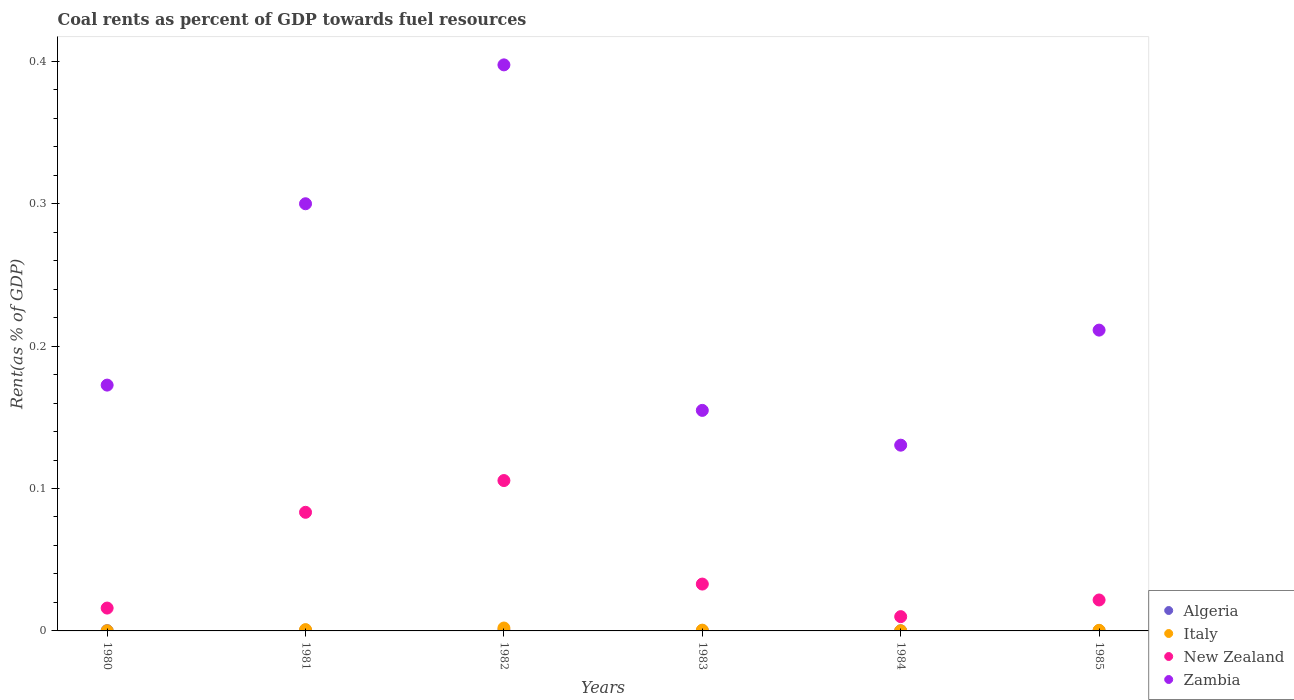How many different coloured dotlines are there?
Ensure brevity in your answer.  4. Is the number of dotlines equal to the number of legend labels?
Your answer should be compact. Yes. What is the coal rent in Zambia in 1980?
Your answer should be very brief. 0.17. Across all years, what is the maximum coal rent in Italy?
Your answer should be compact. 0. Across all years, what is the minimum coal rent in Italy?
Give a very brief answer. 9.6418290567852e-5. In which year was the coal rent in New Zealand maximum?
Make the answer very short. 1982. In which year was the coal rent in Algeria minimum?
Offer a terse response. 1984. What is the total coal rent in Italy in the graph?
Give a very brief answer. 0. What is the difference between the coal rent in Italy in 1980 and that in 1983?
Your answer should be compact. -0. What is the difference between the coal rent in Zambia in 1984 and the coal rent in Italy in 1983?
Provide a short and direct response. 0.13. What is the average coal rent in Algeria per year?
Provide a succinct answer. 0. In the year 1984, what is the difference between the coal rent in New Zealand and coal rent in Italy?
Give a very brief answer. 0.01. In how many years, is the coal rent in New Zealand greater than 0.12000000000000001 %?
Keep it short and to the point. 0. What is the ratio of the coal rent in Italy in 1981 to that in 1985?
Make the answer very short. 2.21. Is the coal rent in New Zealand in 1981 less than that in 1985?
Offer a terse response. No. Is the difference between the coal rent in New Zealand in 1983 and 1984 greater than the difference between the coal rent in Italy in 1983 and 1984?
Give a very brief answer. Yes. What is the difference between the highest and the second highest coal rent in Italy?
Offer a very short reply. 0. What is the difference between the highest and the lowest coal rent in New Zealand?
Provide a succinct answer. 0.1. In how many years, is the coal rent in New Zealand greater than the average coal rent in New Zealand taken over all years?
Offer a terse response. 2. Is the sum of the coal rent in Italy in 1981 and 1984 greater than the maximum coal rent in New Zealand across all years?
Ensure brevity in your answer.  No. Is it the case that in every year, the sum of the coal rent in Algeria and coal rent in Italy  is greater than the sum of coal rent in Zambia and coal rent in New Zealand?
Give a very brief answer. No. Does the coal rent in Zambia monotonically increase over the years?
Keep it short and to the point. No. Is the coal rent in Algeria strictly less than the coal rent in New Zealand over the years?
Your response must be concise. Yes. Are the values on the major ticks of Y-axis written in scientific E-notation?
Offer a terse response. No. Does the graph contain any zero values?
Ensure brevity in your answer.  No. How many legend labels are there?
Your response must be concise. 4. How are the legend labels stacked?
Offer a terse response. Vertical. What is the title of the graph?
Your answer should be compact. Coal rents as percent of GDP towards fuel resources. Does "Fiji" appear as one of the legend labels in the graph?
Provide a succinct answer. No. What is the label or title of the X-axis?
Your answer should be very brief. Years. What is the label or title of the Y-axis?
Provide a succinct answer. Rent(as % of GDP). What is the Rent(as % of GDP) in Algeria in 1980?
Your answer should be very brief. 0. What is the Rent(as % of GDP) in Italy in 1980?
Your response must be concise. 9.6418290567852e-5. What is the Rent(as % of GDP) of New Zealand in 1980?
Give a very brief answer. 0.02. What is the Rent(as % of GDP) of Zambia in 1980?
Make the answer very short. 0.17. What is the Rent(as % of GDP) in Algeria in 1981?
Make the answer very short. 0. What is the Rent(as % of GDP) of Italy in 1981?
Give a very brief answer. 0. What is the Rent(as % of GDP) of New Zealand in 1981?
Give a very brief answer. 0.08. What is the Rent(as % of GDP) of Zambia in 1981?
Offer a very short reply. 0.3. What is the Rent(as % of GDP) of Algeria in 1982?
Your answer should be compact. 0. What is the Rent(as % of GDP) in Italy in 1982?
Offer a terse response. 0. What is the Rent(as % of GDP) of New Zealand in 1982?
Ensure brevity in your answer.  0.11. What is the Rent(as % of GDP) of Zambia in 1982?
Ensure brevity in your answer.  0.4. What is the Rent(as % of GDP) of Algeria in 1983?
Ensure brevity in your answer.  0. What is the Rent(as % of GDP) of Italy in 1983?
Ensure brevity in your answer.  0. What is the Rent(as % of GDP) in New Zealand in 1983?
Your response must be concise. 0.03. What is the Rent(as % of GDP) in Zambia in 1983?
Offer a very short reply. 0.15. What is the Rent(as % of GDP) of Algeria in 1984?
Offer a terse response. 6.52912655872695e-5. What is the Rent(as % of GDP) in Italy in 1984?
Provide a succinct answer. 0. What is the Rent(as % of GDP) of New Zealand in 1984?
Offer a terse response. 0.01. What is the Rent(as % of GDP) of Zambia in 1984?
Your answer should be compact. 0.13. What is the Rent(as % of GDP) in Algeria in 1985?
Make the answer very short. 0. What is the Rent(as % of GDP) in Italy in 1985?
Ensure brevity in your answer.  0. What is the Rent(as % of GDP) in New Zealand in 1985?
Offer a very short reply. 0.02. What is the Rent(as % of GDP) in Zambia in 1985?
Provide a short and direct response. 0.21. Across all years, what is the maximum Rent(as % of GDP) in Algeria?
Keep it short and to the point. 0. Across all years, what is the maximum Rent(as % of GDP) of Italy?
Your answer should be compact. 0. Across all years, what is the maximum Rent(as % of GDP) of New Zealand?
Provide a succinct answer. 0.11. Across all years, what is the maximum Rent(as % of GDP) of Zambia?
Give a very brief answer. 0.4. Across all years, what is the minimum Rent(as % of GDP) of Algeria?
Your answer should be compact. 6.52912655872695e-5. Across all years, what is the minimum Rent(as % of GDP) in Italy?
Offer a very short reply. 9.6418290567852e-5. Across all years, what is the minimum Rent(as % of GDP) of New Zealand?
Keep it short and to the point. 0.01. Across all years, what is the minimum Rent(as % of GDP) of Zambia?
Your answer should be compact. 0.13. What is the total Rent(as % of GDP) of Algeria in the graph?
Your answer should be compact. 0. What is the total Rent(as % of GDP) in Italy in the graph?
Make the answer very short. 0. What is the total Rent(as % of GDP) of New Zealand in the graph?
Make the answer very short. 0.27. What is the total Rent(as % of GDP) in Zambia in the graph?
Your response must be concise. 1.37. What is the difference between the Rent(as % of GDP) of Algeria in 1980 and that in 1981?
Your answer should be compact. -0. What is the difference between the Rent(as % of GDP) in Italy in 1980 and that in 1981?
Ensure brevity in your answer.  -0. What is the difference between the Rent(as % of GDP) in New Zealand in 1980 and that in 1981?
Offer a very short reply. -0.07. What is the difference between the Rent(as % of GDP) in Zambia in 1980 and that in 1981?
Keep it short and to the point. -0.13. What is the difference between the Rent(as % of GDP) in Algeria in 1980 and that in 1982?
Provide a short and direct response. -0. What is the difference between the Rent(as % of GDP) of Italy in 1980 and that in 1982?
Keep it short and to the point. -0. What is the difference between the Rent(as % of GDP) in New Zealand in 1980 and that in 1982?
Make the answer very short. -0.09. What is the difference between the Rent(as % of GDP) of Zambia in 1980 and that in 1982?
Your answer should be compact. -0.22. What is the difference between the Rent(as % of GDP) of Italy in 1980 and that in 1983?
Give a very brief answer. -0. What is the difference between the Rent(as % of GDP) of New Zealand in 1980 and that in 1983?
Give a very brief answer. -0.02. What is the difference between the Rent(as % of GDP) of Zambia in 1980 and that in 1983?
Provide a succinct answer. 0.02. What is the difference between the Rent(as % of GDP) in Algeria in 1980 and that in 1984?
Offer a terse response. 0. What is the difference between the Rent(as % of GDP) of Italy in 1980 and that in 1984?
Offer a very short reply. -0. What is the difference between the Rent(as % of GDP) of New Zealand in 1980 and that in 1984?
Provide a succinct answer. 0.01. What is the difference between the Rent(as % of GDP) of Zambia in 1980 and that in 1984?
Provide a succinct answer. 0.04. What is the difference between the Rent(as % of GDP) in Italy in 1980 and that in 1985?
Keep it short and to the point. -0. What is the difference between the Rent(as % of GDP) in New Zealand in 1980 and that in 1985?
Your answer should be compact. -0.01. What is the difference between the Rent(as % of GDP) in Zambia in 1980 and that in 1985?
Your response must be concise. -0.04. What is the difference between the Rent(as % of GDP) of Algeria in 1981 and that in 1982?
Offer a terse response. -0. What is the difference between the Rent(as % of GDP) in Italy in 1981 and that in 1982?
Provide a short and direct response. -0. What is the difference between the Rent(as % of GDP) in New Zealand in 1981 and that in 1982?
Offer a very short reply. -0.02. What is the difference between the Rent(as % of GDP) of Zambia in 1981 and that in 1982?
Keep it short and to the point. -0.1. What is the difference between the Rent(as % of GDP) of Algeria in 1981 and that in 1983?
Your response must be concise. 0. What is the difference between the Rent(as % of GDP) in Italy in 1981 and that in 1983?
Give a very brief answer. 0. What is the difference between the Rent(as % of GDP) in New Zealand in 1981 and that in 1983?
Provide a succinct answer. 0.05. What is the difference between the Rent(as % of GDP) in Zambia in 1981 and that in 1983?
Provide a short and direct response. 0.15. What is the difference between the Rent(as % of GDP) in Italy in 1981 and that in 1984?
Provide a succinct answer. 0. What is the difference between the Rent(as % of GDP) in New Zealand in 1981 and that in 1984?
Offer a very short reply. 0.07. What is the difference between the Rent(as % of GDP) of Zambia in 1981 and that in 1984?
Your response must be concise. 0.17. What is the difference between the Rent(as % of GDP) in Algeria in 1981 and that in 1985?
Make the answer very short. 0. What is the difference between the Rent(as % of GDP) in Italy in 1981 and that in 1985?
Give a very brief answer. 0. What is the difference between the Rent(as % of GDP) of New Zealand in 1981 and that in 1985?
Your response must be concise. 0.06. What is the difference between the Rent(as % of GDP) in Zambia in 1981 and that in 1985?
Give a very brief answer. 0.09. What is the difference between the Rent(as % of GDP) in Algeria in 1982 and that in 1983?
Offer a very short reply. 0. What is the difference between the Rent(as % of GDP) in Italy in 1982 and that in 1983?
Your answer should be very brief. 0. What is the difference between the Rent(as % of GDP) in New Zealand in 1982 and that in 1983?
Make the answer very short. 0.07. What is the difference between the Rent(as % of GDP) in Zambia in 1982 and that in 1983?
Your response must be concise. 0.24. What is the difference between the Rent(as % of GDP) of Italy in 1982 and that in 1984?
Keep it short and to the point. 0. What is the difference between the Rent(as % of GDP) of New Zealand in 1982 and that in 1984?
Ensure brevity in your answer.  0.1. What is the difference between the Rent(as % of GDP) in Zambia in 1982 and that in 1984?
Your answer should be compact. 0.27. What is the difference between the Rent(as % of GDP) of Algeria in 1982 and that in 1985?
Give a very brief answer. 0. What is the difference between the Rent(as % of GDP) of Italy in 1982 and that in 1985?
Provide a succinct answer. 0. What is the difference between the Rent(as % of GDP) of New Zealand in 1982 and that in 1985?
Ensure brevity in your answer.  0.08. What is the difference between the Rent(as % of GDP) of Zambia in 1982 and that in 1985?
Give a very brief answer. 0.19. What is the difference between the Rent(as % of GDP) in Algeria in 1983 and that in 1984?
Your answer should be compact. 0. What is the difference between the Rent(as % of GDP) in New Zealand in 1983 and that in 1984?
Provide a short and direct response. 0.02. What is the difference between the Rent(as % of GDP) in Zambia in 1983 and that in 1984?
Offer a terse response. 0.02. What is the difference between the Rent(as % of GDP) in Algeria in 1983 and that in 1985?
Give a very brief answer. 0. What is the difference between the Rent(as % of GDP) in New Zealand in 1983 and that in 1985?
Your answer should be very brief. 0.01. What is the difference between the Rent(as % of GDP) in Zambia in 1983 and that in 1985?
Provide a short and direct response. -0.06. What is the difference between the Rent(as % of GDP) of Italy in 1984 and that in 1985?
Provide a succinct answer. -0. What is the difference between the Rent(as % of GDP) in New Zealand in 1984 and that in 1985?
Make the answer very short. -0.01. What is the difference between the Rent(as % of GDP) in Zambia in 1984 and that in 1985?
Your answer should be very brief. -0.08. What is the difference between the Rent(as % of GDP) of Algeria in 1980 and the Rent(as % of GDP) of Italy in 1981?
Make the answer very short. -0. What is the difference between the Rent(as % of GDP) of Algeria in 1980 and the Rent(as % of GDP) of New Zealand in 1981?
Offer a terse response. -0.08. What is the difference between the Rent(as % of GDP) of Algeria in 1980 and the Rent(as % of GDP) of Zambia in 1981?
Make the answer very short. -0.3. What is the difference between the Rent(as % of GDP) of Italy in 1980 and the Rent(as % of GDP) of New Zealand in 1981?
Keep it short and to the point. -0.08. What is the difference between the Rent(as % of GDP) in Italy in 1980 and the Rent(as % of GDP) in Zambia in 1981?
Give a very brief answer. -0.3. What is the difference between the Rent(as % of GDP) in New Zealand in 1980 and the Rent(as % of GDP) in Zambia in 1981?
Keep it short and to the point. -0.28. What is the difference between the Rent(as % of GDP) of Algeria in 1980 and the Rent(as % of GDP) of Italy in 1982?
Your response must be concise. -0. What is the difference between the Rent(as % of GDP) in Algeria in 1980 and the Rent(as % of GDP) in New Zealand in 1982?
Ensure brevity in your answer.  -0.11. What is the difference between the Rent(as % of GDP) of Algeria in 1980 and the Rent(as % of GDP) of Zambia in 1982?
Keep it short and to the point. -0.4. What is the difference between the Rent(as % of GDP) of Italy in 1980 and the Rent(as % of GDP) of New Zealand in 1982?
Provide a succinct answer. -0.11. What is the difference between the Rent(as % of GDP) of Italy in 1980 and the Rent(as % of GDP) of Zambia in 1982?
Provide a succinct answer. -0.4. What is the difference between the Rent(as % of GDP) in New Zealand in 1980 and the Rent(as % of GDP) in Zambia in 1982?
Provide a succinct answer. -0.38. What is the difference between the Rent(as % of GDP) in Algeria in 1980 and the Rent(as % of GDP) in Italy in 1983?
Offer a very short reply. -0. What is the difference between the Rent(as % of GDP) in Algeria in 1980 and the Rent(as % of GDP) in New Zealand in 1983?
Your answer should be compact. -0.03. What is the difference between the Rent(as % of GDP) of Algeria in 1980 and the Rent(as % of GDP) of Zambia in 1983?
Give a very brief answer. -0.15. What is the difference between the Rent(as % of GDP) of Italy in 1980 and the Rent(as % of GDP) of New Zealand in 1983?
Provide a short and direct response. -0.03. What is the difference between the Rent(as % of GDP) of Italy in 1980 and the Rent(as % of GDP) of Zambia in 1983?
Give a very brief answer. -0.15. What is the difference between the Rent(as % of GDP) in New Zealand in 1980 and the Rent(as % of GDP) in Zambia in 1983?
Provide a short and direct response. -0.14. What is the difference between the Rent(as % of GDP) of Algeria in 1980 and the Rent(as % of GDP) of Italy in 1984?
Provide a short and direct response. 0. What is the difference between the Rent(as % of GDP) of Algeria in 1980 and the Rent(as % of GDP) of New Zealand in 1984?
Keep it short and to the point. -0.01. What is the difference between the Rent(as % of GDP) of Algeria in 1980 and the Rent(as % of GDP) of Zambia in 1984?
Offer a very short reply. -0.13. What is the difference between the Rent(as % of GDP) of Italy in 1980 and the Rent(as % of GDP) of New Zealand in 1984?
Offer a very short reply. -0.01. What is the difference between the Rent(as % of GDP) in Italy in 1980 and the Rent(as % of GDP) in Zambia in 1984?
Provide a short and direct response. -0.13. What is the difference between the Rent(as % of GDP) of New Zealand in 1980 and the Rent(as % of GDP) of Zambia in 1984?
Provide a succinct answer. -0.11. What is the difference between the Rent(as % of GDP) of Algeria in 1980 and the Rent(as % of GDP) of Italy in 1985?
Offer a very short reply. -0. What is the difference between the Rent(as % of GDP) of Algeria in 1980 and the Rent(as % of GDP) of New Zealand in 1985?
Your answer should be very brief. -0.02. What is the difference between the Rent(as % of GDP) in Algeria in 1980 and the Rent(as % of GDP) in Zambia in 1985?
Provide a succinct answer. -0.21. What is the difference between the Rent(as % of GDP) of Italy in 1980 and the Rent(as % of GDP) of New Zealand in 1985?
Your answer should be compact. -0.02. What is the difference between the Rent(as % of GDP) of Italy in 1980 and the Rent(as % of GDP) of Zambia in 1985?
Provide a succinct answer. -0.21. What is the difference between the Rent(as % of GDP) in New Zealand in 1980 and the Rent(as % of GDP) in Zambia in 1985?
Give a very brief answer. -0.2. What is the difference between the Rent(as % of GDP) in Algeria in 1981 and the Rent(as % of GDP) in Italy in 1982?
Provide a succinct answer. -0. What is the difference between the Rent(as % of GDP) of Algeria in 1981 and the Rent(as % of GDP) of New Zealand in 1982?
Keep it short and to the point. -0.11. What is the difference between the Rent(as % of GDP) in Algeria in 1981 and the Rent(as % of GDP) in Zambia in 1982?
Provide a short and direct response. -0.4. What is the difference between the Rent(as % of GDP) of Italy in 1981 and the Rent(as % of GDP) of New Zealand in 1982?
Your response must be concise. -0.1. What is the difference between the Rent(as % of GDP) in Italy in 1981 and the Rent(as % of GDP) in Zambia in 1982?
Make the answer very short. -0.4. What is the difference between the Rent(as % of GDP) in New Zealand in 1981 and the Rent(as % of GDP) in Zambia in 1982?
Provide a short and direct response. -0.31. What is the difference between the Rent(as % of GDP) of Algeria in 1981 and the Rent(as % of GDP) of Italy in 1983?
Offer a terse response. -0. What is the difference between the Rent(as % of GDP) in Algeria in 1981 and the Rent(as % of GDP) in New Zealand in 1983?
Offer a terse response. -0.03. What is the difference between the Rent(as % of GDP) of Algeria in 1981 and the Rent(as % of GDP) of Zambia in 1983?
Make the answer very short. -0.15. What is the difference between the Rent(as % of GDP) in Italy in 1981 and the Rent(as % of GDP) in New Zealand in 1983?
Your response must be concise. -0.03. What is the difference between the Rent(as % of GDP) of Italy in 1981 and the Rent(as % of GDP) of Zambia in 1983?
Keep it short and to the point. -0.15. What is the difference between the Rent(as % of GDP) of New Zealand in 1981 and the Rent(as % of GDP) of Zambia in 1983?
Make the answer very short. -0.07. What is the difference between the Rent(as % of GDP) of Algeria in 1981 and the Rent(as % of GDP) of New Zealand in 1984?
Offer a very short reply. -0.01. What is the difference between the Rent(as % of GDP) in Algeria in 1981 and the Rent(as % of GDP) in Zambia in 1984?
Provide a short and direct response. -0.13. What is the difference between the Rent(as % of GDP) in Italy in 1981 and the Rent(as % of GDP) in New Zealand in 1984?
Keep it short and to the point. -0.01. What is the difference between the Rent(as % of GDP) of Italy in 1981 and the Rent(as % of GDP) of Zambia in 1984?
Your response must be concise. -0.13. What is the difference between the Rent(as % of GDP) in New Zealand in 1981 and the Rent(as % of GDP) in Zambia in 1984?
Your response must be concise. -0.05. What is the difference between the Rent(as % of GDP) of Algeria in 1981 and the Rent(as % of GDP) of New Zealand in 1985?
Provide a succinct answer. -0.02. What is the difference between the Rent(as % of GDP) of Algeria in 1981 and the Rent(as % of GDP) of Zambia in 1985?
Provide a succinct answer. -0.21. What is the difference between the Rent(as % of GDP) of Italy in 1981 and the Rent(as % of GDP) of New Zealand in 1985?
Provide a succinct answer. -0.02. What is the difference between the Rent(as % of GDP) of Italy in 1981 and the Rent(as % of GDP) of Zambia in 1985?
Provide a succinct answer. -0.21. What is the difference between the Rent(as % of GDP) of New Zealand in 1981 and the Rent(as % of GDP) of Zambia in 1985?
Ensure brevity in your answer.  -0.13. What is the difference between the Rent(as % of GDP) of Algeria in 1982 and the Rent(as % of GDP) of Italy in 1983?
Your answer should be compact. -0. What is the difference between the Rent(as % of GDP) in Algeria in 1982 and the Rent(as % of GDP) in New Zealand in 1983?
Your answer should be very brief. -0.03. What is the difference between the Rent(as % of GDP) of Algeria in 1982 and the Rent(as % of GDP) of Zambia in 1983?
Give a very brief answer. -0.15. What is the difference between the Rent(as % of GDP) of Italy in 1982 and the Rent(as % of GDP) of New Zealand in 1983?
Your answer should be very brief. -0.03. What is the difference between the Rent(as % of GDP) in Italy in 1982 and the Rent(as % of GDP) in Zambia in 1983?
Your response must be concise. -0.15. What is the difference between the Rent(as % of GDP) of New Zealand in 1982 and the Rent(as % of GDP) of Zambia in 1983?
Keep it short and to the point. -0.05. What is the difference between the Rent(as % of GDP) of Algeria in 1982 and the Rent(as % of GDP) of New Zealand in 1984?
Your answer should be compact. -0.01. What is the difference between the Rent(as % of GDP) in Algeria in 1982 and the Rent(as % of GDP) in Zambia in 1984?
Provide a succinct answer. -0.13. What is the difference between the Rent(as % of GDP) of Italy in 1982 and the Rent(as % of GDP) of New Zealand in 1984?
Offer a terse response. -0.01. What is the difference between the Rent(as % of GDP) in Italy in 1982 and the Rent(as % of GDP) in Zambia in 1984?
Offer a very short reply. -0.13. What is the difference between the Rent(as % of GDP) of New Zealand in 1982 and the Rent(as % of GDP) of Zambia in 1984?
Offer a very short reply. -0.02. What is the difference between the Rent(as % of GDP) in Algeria in 1982 and the Rent(as % of GDP) in New Zealand in 1985?
Provide a succinct answer. -0.02. What is the difference between the Rent(as % of GDP) in Algeria in 1982 and the Rent(as % of GDP) in Zambia in 1985?
Give a very brief answer. -0.21. What is the difference between the Rent(as % of GDP) of Italy in 1982 and the Rent(as % of GDP) of New Zealand in 1985?
Your response must be concise. -0.02. What is the difference between the Rent(as % of GDP) in Italy in 1982 and the Rent(as % of GDP) in Zambia in 1985?
Make the answer very short. -0.21. What is the difference between the Rent(as % of GDP) in New Zealand in 1982 and the Rent(as % of GDP) in Zambia in 1985?
Your answer should be compact. -0.11. What is the difference between the Rent(as % of GDP) of Algeria in 1983 and the Rent(as % of GDP) of Italy in 1984?
Your answer should be compact. 0. What is the difference between the Rent(as % of GDP) of Algeria in 1983 and the Rent(as % of GDP) of New Zealand in 1984?
Your answer should be compact. -0.01. What is the difference between the Rent(as % of GDP) of Algeria in 1983 and the Rent(as % of GDP) of Zambia in 1984?
Give a very brief answer. -0.13. What is the difference between the Rent(as % of GDP) of Italy in 1983 and the Rent(as % of GDP) of New Zealand in 1984?
Your answer should be very brief. -0.01. What is the difference between the Rent(as % of GDP) of Italy in 1983 and the Rent(as % of GDP) of Zambia in 1984?
Offer a very short reply. -0.13. What is the difference between the Rent(as % of GDP) of New Zealand in 1983 and the Rent(as % of GDP) of Zambia in 1984?
Ensure brevity in your answer.  -0.1. What is the difference between the Rent(as % of GDP) of Algeria in 1983 and the Rent(as % of GDP) of Italy in 1985?
Your answer should be very brief. -0. What is the difference between the Rent(as % of GDP) of Algeria in 1983 and the Rent(as % of GDP) of New Zealand in 1985?
Your response must be concise. -0.02. What is the difference between the Rent(as % of GDP) of Algeria in 1983 and the Rent(as % of GDP) of Zambia in 1985?
Give a very brief answer. -0.21. What is the difference between the Rent(as % of GDP) in Italy in 1983 and the Rent(as % of GDP) in New Zealand in 1985?
Offer a very short reply. -0.02. What is the difference between the Rent(as % of GDP) of Italy in 1983 and the Rent(as % of GDP) of Zambia in 1985?
Ensure brevity in your answer.  -0.21. What is the difference between the Rent(as % of GDP) of New Zealand in 1983 and the Rent(as % of GDP) of Zambia in 1985?
Give a very brief answer. -0.18. What is the difference between the Rent(as % of GDP) of Algeria in 1984 and the Rent(as % of GDP) of Italy in 1985?
Your answer should be very brief. -0. What is the difference between the Rent(as % of GDP) of Algeria in 1984 and the Rent(as % of GDP) of New Zealand in 1985?
Make the answer very short. -0.02. What is the difference between the Rent(as % of GDP) of Algeria in 1984 and the Rent(as % of GDP) of Zambia in 1985?
Your answer should be compact. -0.21. What is the difference between the Rent(as % of GDP) in Italy in 1984 and the Rent(as % of GDP) in New Zealand in 1985?
Provide a succinct answer. -0.02. What is the difference between the Rent(as % of GDP) of Italy in 1984 and the Rent(as % of GDP) of Zambia in 1985?
Give a very brief answer. -0.21. What is the difference between the Rent(as % of GDP) in New Zealand in 1984 and the Rent(as % of GDP) in Zambia in 1985?
Provide a succinct answer. -0.2. What is the average Rent(as % of GDP) of Italy per year?
Keep it short and to the point. 0. What is the average Rent(as % of GDP) in New Zealand per year?
Give a very brief answer. 0.04. What is the average Rent(as % of GDP) in Zambia per year?
Your answer should be compact. 0.23. In the year 1980, what is the difference between the Rent(as % of GDP) in Algeria and Rent(as % of GDP) in Italy?
Offer a terse response. 0. In the year 1980, what is the difference between the Rent(as % of GDP) in Algeria and Rent(as % of GDP) in New Zealand?
Make the answer very short. -0.02. In the year 1980, what is the difference between the Rent(as % of GDP) of Algeria and Rent(as % of GDP) of Zambia?
Your response must be concise. -0.17. In the year 1980, what is the difference between the Rent(as % of GDP) in Italy and Rent(as % of GDP) in New Zealand?
Keep it short and to the point. -0.02. In the year 1980, what is the difference between the Rent(as % of GDP) of Italy and Rent(as % of GDP) of Zambia?
Give a very brief answer. -0.17. In the year 1980, what is the difference between the Rent(as % of GDP) of New Zealand and Rent(as % of GDP) of Zambia?
Your answer should be very brief. -0.16. In the year 1981, what is the difference between the Rent(as % of GDP) in Algeria and Rent(as % of GDP) in Italy?
Your answer should be very brief. -0. In the year 1981, what is the difference between the Rent(as % of GDP) of Algeria and Rent(as % of GDP) of New Zealand?
Offer a terse response. -0.08. In the year 1981, what is the difference between the Rent(as % of GDP) of Algeria and Rent(as % of GDP) of Zambia?
Provide a succinct answer. -0.3. In the year 1981, what is the difference between the Rent(as % of GDP) of Italy and Rent(as % of GDP) of New Zealand?
Your response must be concise. -0.08. In the year 1981, what is the difference between the Rent(as % of GDP) in Italy and Rent(as % of GDP) in Zambia?
Keep it short and to the point. -0.3. In the year 1981, what is the difference between the Rent(as % of GDP) in New Zealand and Rent(as % of GDP) in Zambia?
Your answer should be compact. -0.22. In the year 1982, what is the difference between the Rent(as % of GDP) of Algeria and Rent(as % of GDP) of Italy?
Offer a terse response. -0. In the year 1982, what is the difference between the Rent(as % of GDP) in Algeria and Rent(as % of GDP) in New Zealand?
Offer a terse response. -0.11. In the year 1982, what is the difference between the Rent(as % of GDP) of Algeria and Rent(as % of GDP) of Zambia?
Offer a terse response. -0.4. In the year 1982, what is the difference between the Rent(as % of GDP) of Italy and Rent(as % of GDP) of New Zealand?
Your response must be concise. -0.1. In the year 1982, what is the difference between the Rent(as % of GDP) in Italy and Rent(as % of GDP) in Zambia?
Your response must be concise. -0.4. In the year 1982, what is the difference between the Rent(as % of GDP) in New Zealand and Rent(as % of GDP) in Zambia?
Offer a terse response. -0.29. In the year 1983, what is the difference between the Rent(as % of GDP) in Algeria and Rent(as % of GDP) in Italy?
Your response must be concise. -0. In the year 1983, what is the difference between the Rent(as % of GDP) of Algeria and Rent(as % of GDP) of New Zealand?
Provide a succinct answer. -0.03. In the year 1983, what is the difference between the Rent(as % of GDP) of Algeria and Rent(as % of GDP) of Zambia?
Your answer should be compact. -0.15. In the year 1983, what is the difference between the Rent(as % of GDP) in Italy and Rent(as % of GDP) in New Zealand?
Give a very brief answer. -0.03. In the year 1983, what is the difference between the Rent(as % of GDP) in Italy and Rent(as % of GDP) in Zambia?
Offer a terse response. -0.15. In the year 1983, what is the difference between the Rent(as % of GDP) in New Zealand and Rent(as % of GDP) in Zambia?
Your answer should be very brief. -0.12. In the year 1984, what is the difference between the Rent(as % of GDP) in Algeria and Rent(as % of GDP) in Italy?
Make the answer very short. -0. In the year 1984, what is the difference between the Rent(as % of GDP) of Algeria and Rent(as % of GDP) of New Zealand?
Make the answer very short. -0.01. In the year 1984, what is the difference between the Rent(as % of GDP) in Algeria and Rent(as % of GDP) in Zambia?
Offer a very short reply. -0.13. In the year 1984, what is the difference between the Rent(as % of GDP) in Italy and Rent(as % of GDP) in New Zealand?
Make the answer very short. -0.01. In the year 1984, what is the difference between the Rent(as % of GDP) in Italy and Rent(as % of GDP) in Zambia?
Offer a very short reply. -0.13. In the year 1984, what is the difference between the Rent(as % of GDP) of New Zealand and Rent(as % of GDP) of Zambia?
Provide a succinct answer. -0.12. In the year 1985, what is the difference between the Rent(as % of GDP) of Algeria and Rent(as % of GDP) of Italy?
Provide a succinct answer. -0. In the year 1985, what is the difference between the Rent(as % of GDP) of Algeria and Rent(as % of GDP) of New Zealand?
Keep it short and to the point. -0.02. In the year 1985, what is the difference between the Rent(as % of GDP) in Algeria and Rent(as % of GDP) in Zambia?
Offer a very short reply. -0.21. In the year 1985, what is the difference between the Rent(as % of GDP) in Italy and Rent(as % of GDP) in New Zealand?
Your answer should be compact. -0.02. In the year 1985, what is the difference between the Rent(as % of GDP) in Italy and Rent(as % of GDP) in Zambia?
Give a very brief answer. -0.21. In the year 1985, what is the difference between the Rent(as % of GDP) of New Zealand and Rent(as % of GDP) of Zambia?
Your answer should be very brief. -0.19. What is the ratio of the Rent(as % of GDP) of Algeria in 1980 to that in 1981?
Your response must be concise. 0.45. What is the ratio of the Rent(as % of GDP) in Italy in 1980 to that in 1981?
Keep it short and to the point. 0.1. What is the ratio of the Rent(as % of GDP) of New Zealand in 1980 to that in 1981?
Your answer should be very brief. 0.19. What is the ratio of the Rent(as % of GDP) of Zambia in 1980 to that in 1981?
Provide a short and direct response. 0.58. What is the ratio of the Rent(as % of GDP) of Algeria in 1980 to that in 1982?
Offer a terse response. 0.42. What is the ratio of the Rent(as % of GDP) of Italy in 1980 to that in 1982?
Make the answer very short. 0.05. What is the ratio of the Rent(as % of GDP) of New Zealand in 1980 to that in 1982?
Offer a terse response. 0.15. What is the ratio of the Rent(as % of GDP) of Zambia in 1980 to that in 1982?
Offer a very short reply. 0.43. What is the ratio of the Rent(as % of GDP) in Algeria in 1980 to that in 1983?
Give a very brief answer. 1.18. What is the ratio of the Rent(as % of GDP) of Italy in 1980 to that in 1983?
Ensure brevity in your answer.  0.18. What is the ratio of the Rent(as % of GDP) in New Zealand in 1980 to that in 1983?
Your response must be concise. 0.49. What is the ratio of the Rent(as % of GDP) in Zambia in 1980 to that in 1983?
Give a very brief answer. 1.11. What is the ratio of the Rent(as % of GDP) in Algeria in 1980 to that in 1984?
Ensure brevity in your answer.  2.59. What is the ratio of the Rent(as % of GDP) in Italy in 1980 to that in 1984?
Your answer should be compact. 0.79. What is the ratio of the Rent(as % of GDP) in New Zealand in 1980 to that in 1984?
Your answer should be compact. 1.6. What is the ratio of the Rent(as % of GDP) of Zambia in 1980 to that in 1984?
Make the answer very short. 1.32. What is the ratio of the Rent(as % of GDP) of Algeria in 1980 to that in 1985?
Provide a succinct answer. 1.57. What is the ratio of the Rent(as % of GDP) in Italy in 1980 to that in 1985?
Your response must be concise. 0.23. What is the ratio of the Rent(as % of GDP) of New Zealand in 1980 to that in 1985?
Offer a terse response. 0.74. What is the ratio of the Rent(as % of GDP) in Zambia in 1980 to that in 1985?
Keep it short and to the point. 0.82. What is the ratio of the Rent(as % of GDP) of Algeria in 1981 to that in 1982?
Keep it short and to the point. 0.94. What is the ratio of the Rent(as % of GDP) in Italy in 1981 to that in 1982?
Your answer should be very brief. 0.46. What is the ratio of the Rent(as % of GDP) of New Zealand in 1981 to that in 1982?
Provide a succinct answer. 0.79. What is the ratio of the Rent(as % of GDP) in Zambia in 1981 to that in 1982?
Provide a short and direct response. 0.75. What is the ratio of the Rent(as % of GDP) of Algeria in 1981 to that in 1983?
Offer a very short reply. 2.63. What is the ratio of the Rent(as % of GDP) of Italy in 1981 to that in 1983?
Your answer should be compact. 1.73. What is the ratio of the Rent(as % of GDP) of New Zealand in 1981 to that in 1983?
Give a very brief answer. 2.53. What is the ratio of the Rent(as % of GDP) of Zambia in 1981 to that in 1983?
Make the answer very short. 1.94. What is the ratio of the Rent(as % of GDP) in Algeria in 1981 to that in 1984?
Keep it short and to the point. 5.77. What is the ratio of the Rent(as % of GDP) in Italy in 1981 to that in 1984?
Your answer should be very brief. 7.64. What is the ratio of the Rent(as % of GDP) of New Zealand in 1981 to that in 1984?
Your response must be concise. 8.31. What is the ratio of the Rent(as % of GDP) of Zambia in 1981 to that in 1984?
Make the answer very short. 2.3. What is the ratio of the Rent(as % of GDP) of Algeria in 1981 to that in 1985?
Your answer should be very brief. 3.49. What is the ratio of the Rent(as % of GDP) of Italy in 1981 to that in 1985?
Provide a succinct answer. 2.21. What is the ratio of the Rent(as % of GDP) in New Zealand in 1981 to that in 1985?
Give a very brief answer. 3.83. What is the ratio of the Rent(as % of GDP) of Zambia in 1981 to that in 1985?
Your response must be concise. 1.42. What is the ratio of the Rent(as % of GDP) of Algeria in 1982 to that in 1983?
Make the answer very short. 2.81. What is the ratio of the Rent(as % of GDP) in Italy in 1982 to that in 1983?
Keep it short and to the point. 3.79. What is the ratio of the Rent(as % of GDP) in New Zealand in 1982 to that in 1983?
Your answer should be compact. 3.21. What is the ratio of the Rent(as % of GDP) in Zambia in 1982 to that in 1983?
Ensure brevity in your answer.  2.57. What is the ratio of the Rent(as % of GDP) of Algeria in 1982 to that in 1984?
Provide a short and direct response. 6.15. What is the ratio of the Rent(as % of GDP) in Italy in 1982 to that in 1984?
Your answer should be compact. 16.69. What is the ratio of the Rent(as % of GDP) in New Zealand in 1982 to that in 1984?
Provide a succinct answer. 10.54. What is the ratio of the Rent(as % of GDP) in Zambia in 1982 to that in 1984?
Offer a terse response. 3.05. What is the ratio of the Rent(as % of GDP) of Algeria in 1982 to that in 1985?
Offer a terse response. 3.72. What is the ratio of the Rent(as % of GDP) of Italy in 1982 to that in 1985?
Your answer should be very brief. 4.82. What is the ratio of the Rent(as % of GDP) of New Zealand in 1982 to that in 1985?
Keep it short and to the point. 4.86. What is the ratio of the Rent(as % of GDP) of Zambia in 1982 to that in 1985?
Your answer should be very brief. 1.88. What is the ratio of the Rent(as % of GDP) of Algeria in 1983 to that in 1984?
Offer a very short reply. 2.19. What is the ratio of the Rent(as % of GDP) in Italy in 1983 to that in 1984?
Ensure brevity in your answer.  4.41. What is the ratio of the Rent(as % of GDP) in New Zealand in 1983 to that in 1984?
Offer a very short reply. 3.28. What is the ratio of the Rent(as % of GDP) of Zambia in 1983 to that in 1984?
Your answer should be compact. 1.19. What is the ratio of the Rent(as % of GDP) in Algeria in 1983 to that in 1985?
Keep it short and to the point. 1.32. What is the ratio of the Rent(as % of GDP) in Italy in 1983 to that in 1985?
Make the answer very short. 1.27. What is the ratio of the Rent(as % of GDP) in New Zealand in 1983 to that in 1985?
Your answer should be very brief. 1.51. What is the ratio of the Rent(as % of GDP) of Zambia in 1983 to that in 1985?
Offer a very short reply. 0.73. What is the ratio of the Rent(as % of GDP) of Algeria in 1984 to that in 1985?
Your answer should be compact. 0.6. What is the ratio of the Rent(as % of GDP) in Italy in 1984 to that in 1985?
Ensure brevity in your answer.  0.29. What is the ratio of the Rent(as % of GDP) in New Zealand in 1984 to that in 1985?
Your answer should be compact. 0.46. What is the ratio of the Rent(as % of GDP) of Zambia in 1984 to that in 1985?
Provide a succinct answer. 0.62. What is the difference between the highest and the second highest Rent(as % of GDP) of Algeria?
Your response must be concise. 0. What is the difference between the highest and the second highest Rent(as % of GDP) in Italy?
Ensure brevity in your answer.  0. What is the difference between the highest and the second highest Rent(as % of GDP) in New Zealand?
Your answer should be very brief. 0.02. What is the difference between the highest and the second highest Rent(as % of GDP) of Zambia?
Provide a succinct answer. 0.1. What is the difference between the highest and the lowest Rent(as % of GDP) in Italy?
Provide a succinct answer. 0. What is the difference between the highest and the lowest Rent(as % of GDP) in New Zealand?
Offer a very short reply. 0.1. What is the difference between the highest and the lowest Rent(as % of GDP) in Zambia?
Offer a terse response. 0.27. 